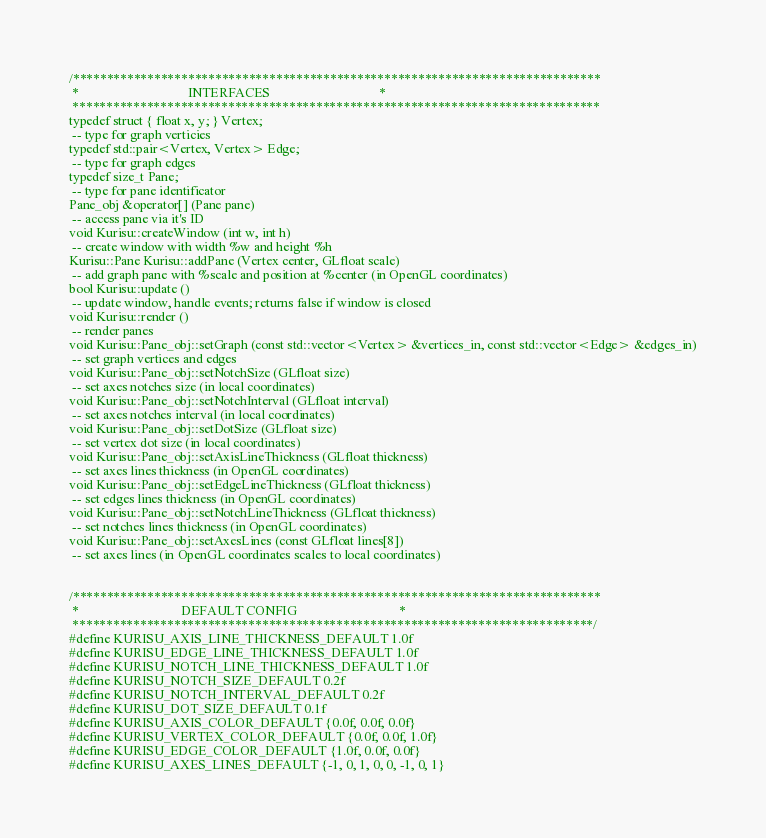Convert code to text. <code><loc_0><loc_0><loc_500><loc_500><_C_>/******************************************************************************
 *                                 INTERFACES                                 *
 ******************************************************************************
typedef struct { float x, y; } Vertex;
 -- type for graph verticies
typedef std::pair<Vertex, Vertex> Edge;
 -- type for graph edges
typedef size_t Pane;
 -- type for pane identificator
Pane_obj &operator[] (Pane pane)
 -- access pane via it's ID
void Kurisu::createWindow (int w, int h)
 -- create window with width %w and height %h
Kurisu::Pane Kurisu::addPane (Vertex center, GLfloat scale)
 -- add graph pane with %scale and position at %center (in OpenGL coordinates)
bool Kurisu::update ()
 -- update window, handle events; returns false if window is closed
void Kurisu::render ()
 -- render panes
void Kurisu::Pane_obj::setGraph (const std::vector<Vertex> &vertices_in, const std::vector<Edge> &edges_in)
 -- set graph vertices and edges
void Kurisu::Pane_obj::setNotchSize (GLfloat size)
 -- set axes notches size (in local coordinates)
void Kurisu::Pane_obj::setNotchInterval (GLfloat interval)
 -- set axes notches interval (in local coordinates)
void Kurisu::Pane_obj::setDotSize (GLfloat size)
 -- set vertex dot size (in local coordinates)
void Kurisu::Pane_obj::setAxisLineThickness (GLfloat thickness)
 -- set axes lines thickness (in OpenGL coordinates)
void Kurisu::Pane_obj::setEdgeLineThickness (GLfloat thickness)
 -- set edges lines thickness (in OpenGL coordinates)
void Kurisu::Pane_obj::setNotchLineThickness (GLfloat thickness)
 -- set notches lines thickness (in OpenGL coordinates)
void Kurisu::Pane_obj::setAxesLines (const GLfloat lines[8])
 -- set axes lines (in OpenGL coordinates scales to local coordinates)


/******************************************************************************
 *                               DEFAULT CONFIG                               *
 *****************************************************************************/
#define KURISU_AXIS_LINE_THICKNESS_DEFAULT 1.0f
#define KURISU_EDGE_LINE_THICKNESS_DEFAULT 1.0f
#define KURISU_NOTCH_LINE_THICKNESS_DEFAULT 1.0f
#define KURISU_NOTCH_SIZE_DEFAULT 0.2f
#define KURISU_NOTCH_INTERVAL_DEFAULT 0.2f
#define KURISU_DOT_SIZE_DEFAULT 0.1f
#define KURISU_AXIS_COLOR_DEFAULT {0.0f, 0.0f, 0.0f}
#define KURISU_VERTEX_COLOR_DEFAULT {0.0f, 0.0f, 1.0f}
#define KURISU_EDGE_COLOR_DEFAULT {1.0f, 0.0f, 0.0f}
#define KURISU_AXES_LINES_DEFAULT {-1, 0, 1, 0, 0, -1, 0, 1}</code> 